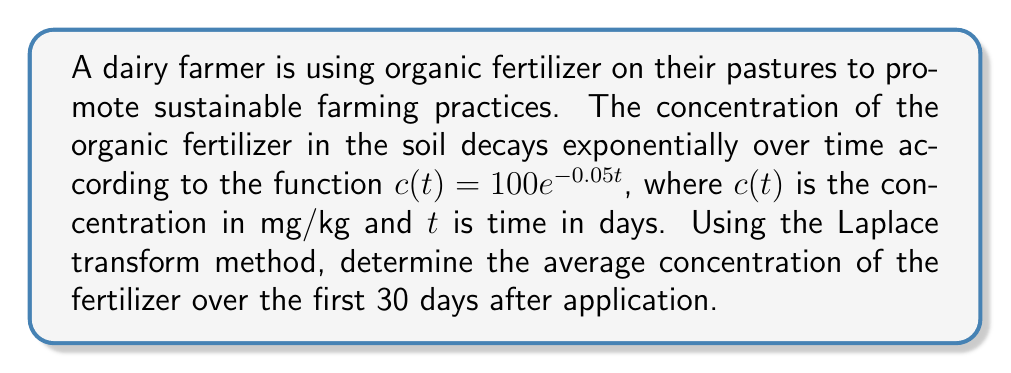Could you help me with this problem? To solve this problem using the Laplace transform method, we'll follow these steps:

1) First, recall that the average value of a function $f(t)$ over an interval $[0,T]$ is given by:

   $$\text{Average} = \frac{1}{T}\int_0^T f(t) dt$$

2) In our case, $f(t) = 100e^{-0.05t}$ and $T = 30$ days.

3) The Laplace transform of $e^{-at}$ is $\frac{1}{s+a}$. Therefore, the Laplace transform of our function is:

   $$\mathcal{L}\{100e^{-0.05t}\} = \frac{100}{s+0.05}$$

4) To find the integral of $c(t)$ from 0 to 30, we can use the following property of Laplace transforms:

   $$\int_0^T f(t) dt = \frac{1}{s}\mathcal{L}\{f(t)\} - \frac{1}{s}\mathcal{L}\{f(t+T)\}$$

5) Applying this to our problem:

   $$\int_0^{30} 100e^{-0.05t} dt = \frac{1}{s}\cdot\frac{100}{s+0.05} - \frac{1}{s}\cdot\frac{100e^{-30s}}{s+0.05}$$

6) To evaluate this at $s=0$ (which corresponds to the time domain), we use L'Hôpital's rule:

   $$\lim_{s\to0} \left(\frac{100}{s+0.05} - \frac{100e^{-30s}}{s+0.05}\right) = \frac{100}{0.05} - \frac{100e^{-30\cdot0.05}}{0.05} = 2000 - 2000e^{-1.5}$$

7) Now, to get the average, we divide by T (30 days):

   $$\text{Average} = \frac{1}{30}(2000 - 2000e^{-1.5}) \approx 44.31 \text{ mg/kg}$$
Answer: The average concentration of the organic fertilizer over the first 30 days after application is approximately 44.31 mg/kg. 